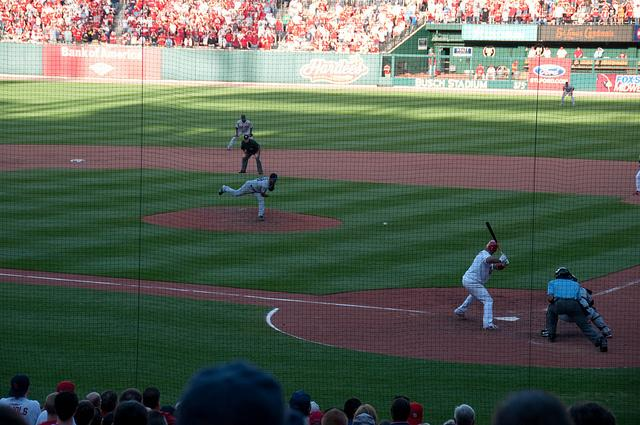What play is the best case scenario for the batter? home run 